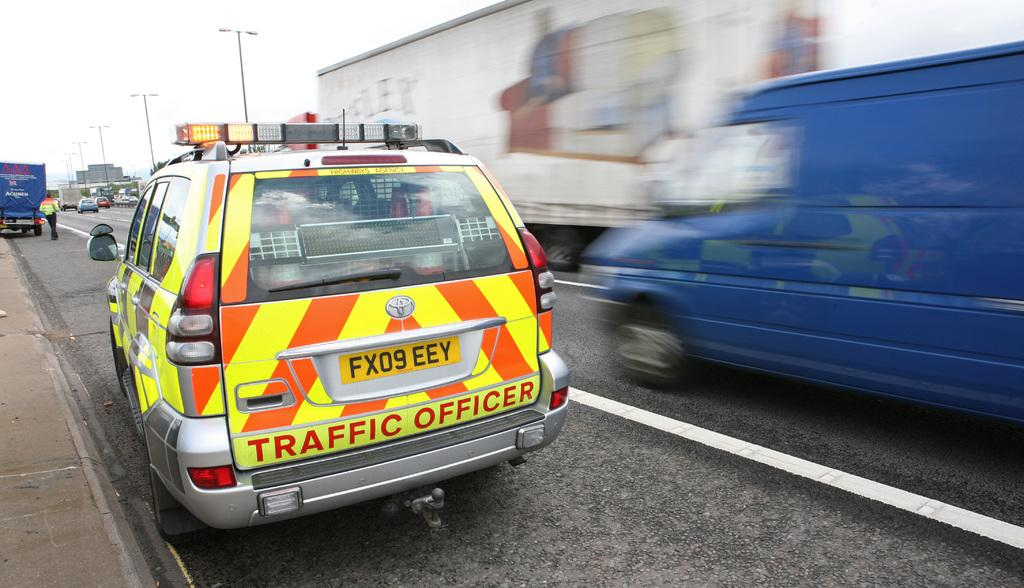<image>
Summarize the visual content of the image. A traffic officer vehicle has a license plate of FX09EEY. 